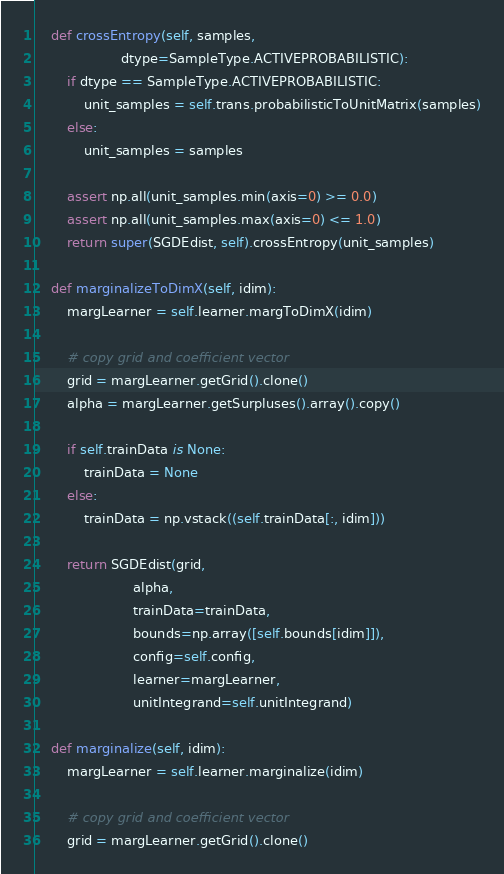Convert code to text. <code><loc_0><loc_0><loc_500><loc_500><_Python_>
    def crossEntropy(self, samples,
                     dtype=SampleType.ACTIVEPROBABILISTIC):
        if dtype == SampleType.ACTIVEPROBABILISTIC:
            unit_samples = self.trans.probabilisticToUnitMatrix(samples)
        else:
            unit_samples = samples

        assert np.all(unit_samples.min(axis=0) >= 0.0)
        assert np.all(unit_samples.max(axis=0) <= 1.0)
        return super(SGDEdist, self).crossEntropy(unit_samples)

    def marginalizeToDimX(self, idim):
        margLearner = self.learner.margToDimX(idim)

        # copy grid and coefficient vector
        grid = margLearner.getGrid().clone()
        alpha = margLearner.getSurpluses().array().copy()

        if self.trainData is None:
            trainData = None
        else:
            trainData = np.vstack((self.trainData[:, idim]))

        return SGDEdist(grid,
                        alpha,
                        trainData=trainData,
                        bounds=np.array([self.bounds[idim]]),
                        config=self.config,
                        learner=margLearner,
                        unitIntegrand=self.unitIntegrand)

    def marginalize(self, idim):
        margLearner = self.learner.marginalize(idim)

        # copy grid and coefficient vector
        grid = margLearner.getGrid().clone()</code> 